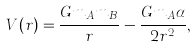Convert formula to latex. <formula><loc_0><loc_0><loc_500><loc_500>V ( r ) = \frac { G m _ { A } m _ { B } } { r } - \frac { G m _ { A } \alpha } { 2 r ^ { 2 } } ,</formula> 